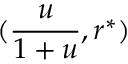<formula> <loc_0><loc_0><loc_500><loc_500>( \frac { u } { 1 + u } , r ^ { * } )</formula> 